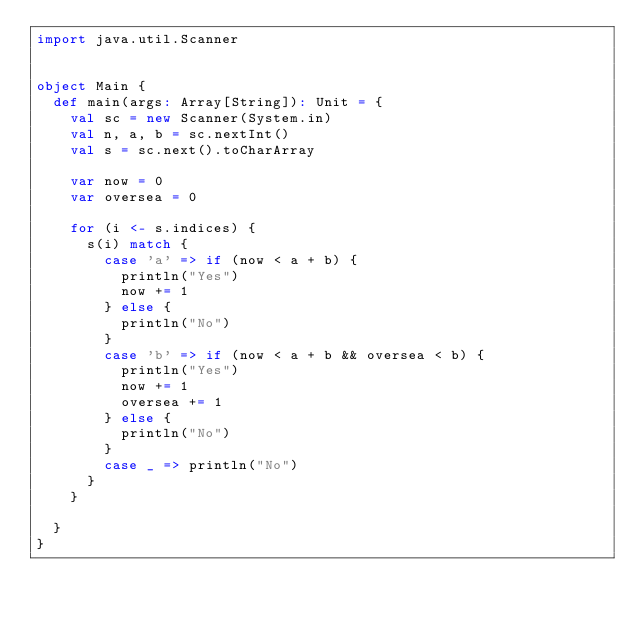Convert code to text. <code><loc_0><loc_0><loc_500><loc_500><_Scala_>import java.util.Scanner


object Main {
  def main(args: Array[String]): Unit = {
    val sc = new Scanner(System.in)
    val n, a, b = sc.nextInt()
    val s = sc.next().toCharArray

    var now = 0
    var oversea = 0

    for (i <- s.indices) {
      s(i) match {
        case 'a' => if (now < a + b) {
          println("Yes")
          now += 1
        } else {
          println("No")
        }
        case 'b' => if (now < a + b && oversea < b) {
          println("Yes")
          now += 1
          oversea += 1
        } else {
          println("No")
        }
        case _ => println("No")
      }
    }

  }
}</code> 